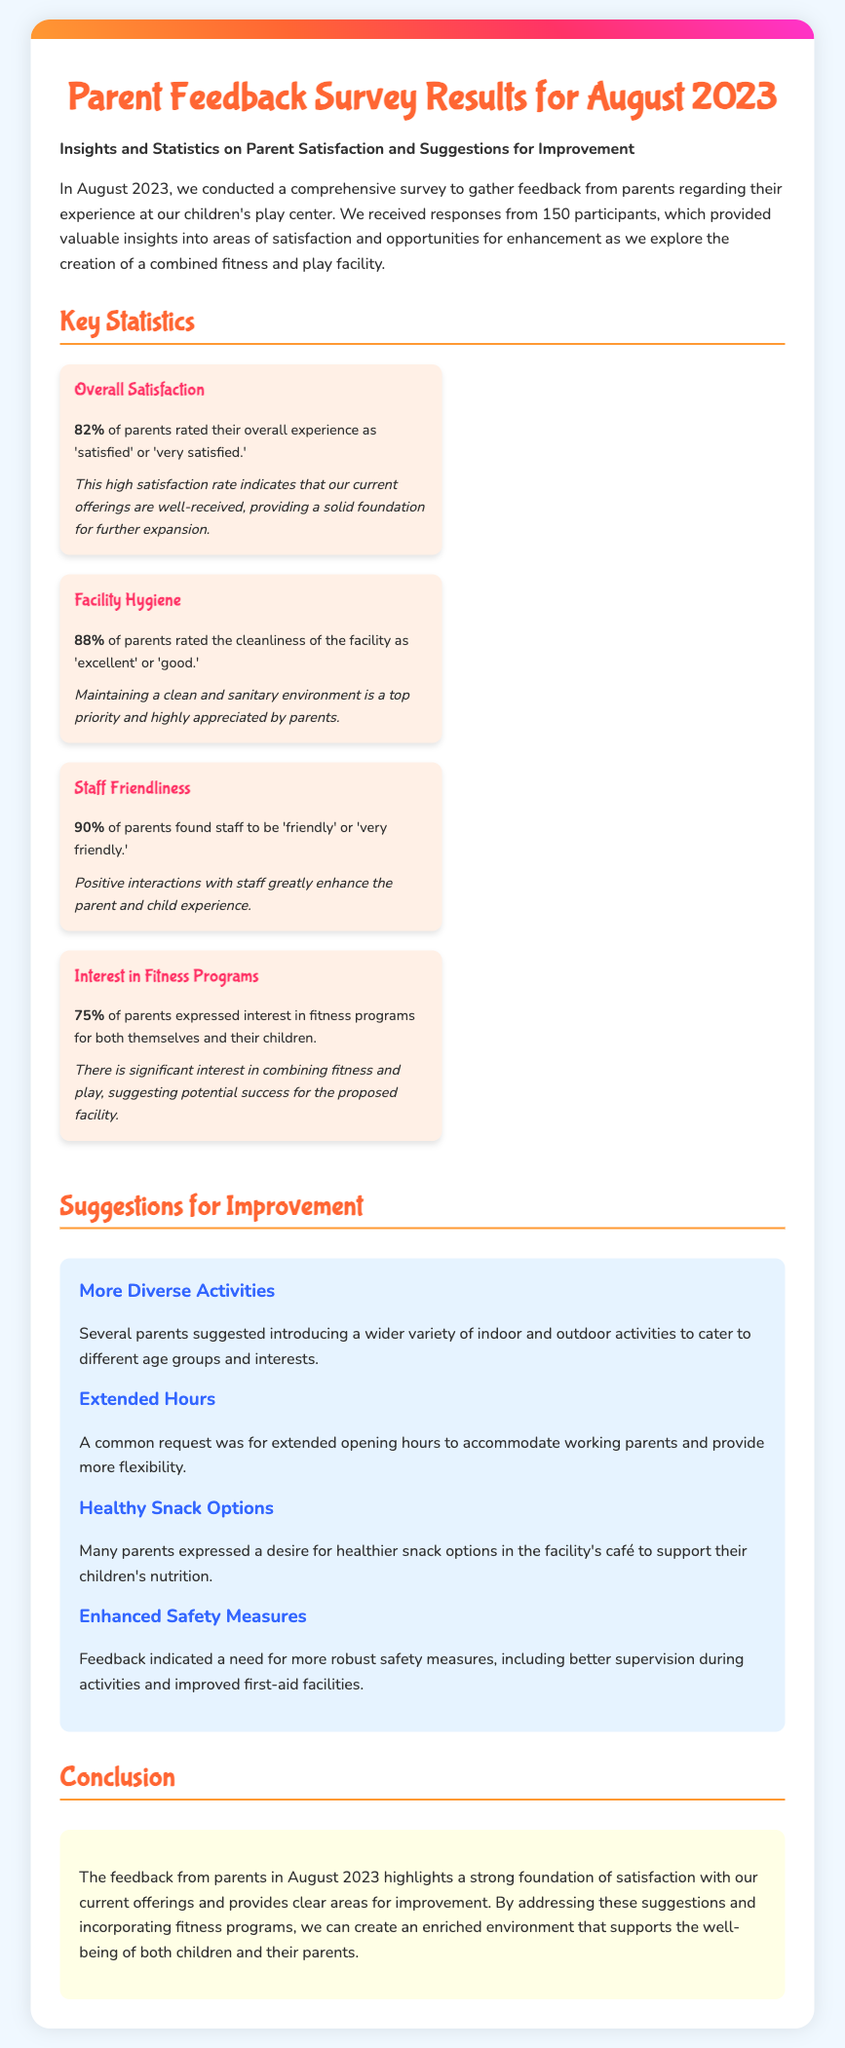What percentage of parents rated their overall experience as 'satisfied' or 'very satisfied'? The document states that 82% of parents rated their overall experience positively.
Answer: 82% What did 88% of parents rate the cleanliness of the facility? The cleanliness was rated as 'excellent' or 'good' by 88% of parents.
Answer: 'excellent' or 'good' What is the interest level in fitness programs among parents? The document indicates that 75% of parents expressed interest in fitness programs.
Answer: 75% What is one suggestion for improvement mentioned by parents? Parents suggested introducing a wider variety of indoor and outdoor activities.
Answer: More diverse activities What was a common request from parents regarding operating hours? The document mentions that parents requested extended opening hours for more flexibility.
Answer: Extended hours What percentage of parents found staff to be 'friendly' or 'very friendly'? According to the document, 90% of parents rated staff friendliness positively.
Answer: 90% What was a key conclusion drawn from the survey results? The conclusion highlights that there is a strong foundation of satisfaction and areas for improvement.
Answer: Strong foundation of satisfaction What overarching trend does the feedback suggest for the proposed facility? The feedback suggests significant interest in combining fitness and play.
Answer: Significant interest in combining fitness and play 